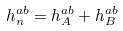Convert formula to latex. <formula><loc_0><loc_0><loc_500><loc_500>h _ { n } ^ { a b } = h _ { A } ^ { a b } + h _ { B } ^ { a b }</formula> 